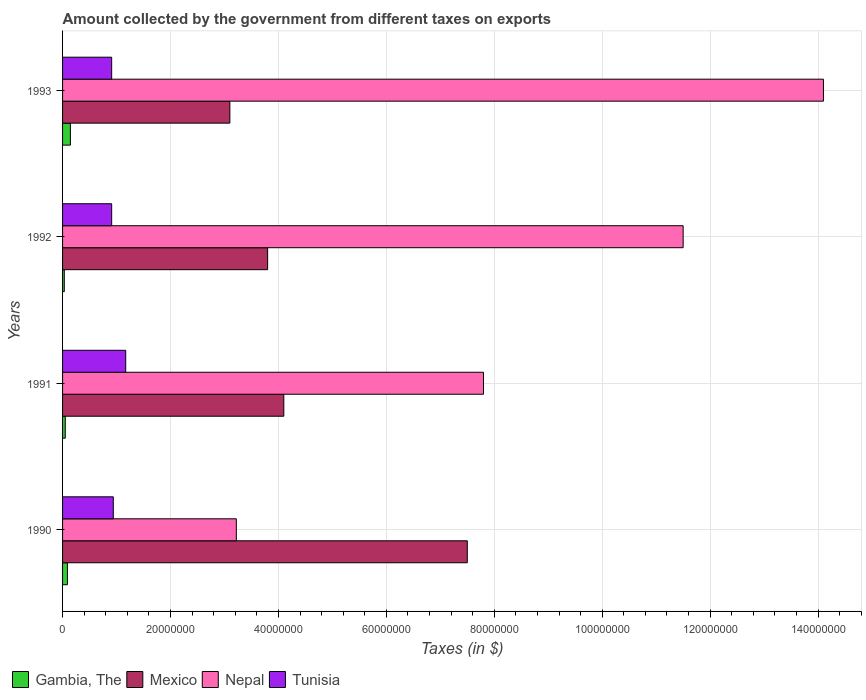How many groups of bars are there?
Your answer should be very brief. 4. Are the number of bars per tick equal to the number of legend labels?
Ensure brevity in your answer.  Yes. Are the number of bars on each tick of the Y-axis equal?
Provide a succinct answer. Yes. What is the amount collected by the government from taxes on exports in Gambia, The in 1990?
Your answer should be very brief. 9.00e+05. Across all years, what is the maximum amount collected by the government from taxes on exports in Gambia, The?
Offer a very short reply. 1.45e+06. Across all years, what is the minimum amount collected by the government from taxes on exports in Gambia, The?
Keep it short and to the point. 3.20e+05. In which year was the amount collected by the government from taxes on exports in Tunisia minimum?
Your answer should be compact. 1992. What is the total amount collected by the government from taxes on exports in Mexico in the graph?
Ensure brevity in your answer.  1.85e+08. What is the difference between the amount collected by the government from taxes on exports in Gambia, The in 1991 and that in 1993?
Give a very brief answer. -9.50e+05. What is the difference between the amount collected by the government from taxes on exports in Gambia, The in 1993 and the amount collected by the government from taxes on exports in Nepal in 1992?
Ensure brevity in your answer.  -1.14e+08. What is the average amount collected by the government from taxes on exports in Nepal per year?
Keep it short and to the point. 9.16e+07. In the year 1991, what is the difference between the amount collected by the government from taxes on exports in Nepal and amount collected by the government from taxes on exports in Mexico?
Your response must be concise. 3.70e+07. What is the ratio of the amount collected by the government from taxes on exports in Nepal in 1990 to that in 1992?
Your answer should be very brief. 0.28. Is the amount collected by the government from taxes on exports in Gambia, The in 1990 less than that in 1992?
Your response must be concise. No. What is the difference between the highest and the second highest amount collected by the government from taxes on exports in Mexico?
Your answer should be very brief. 3.40e+07. What is the difference between the highest and the lowest amount collected by the government from taxes on exports in Tunisia?
Make the answer very short. 2.60e+06. In how many years, is the amount collected by the government from taxes on exports in Nepal greater than the average amount collected by the government from taxes on exports in Nepal taken over all years?
Your response must be concise. 2. Is it the case that in every year, the sum of the amount collected by the government from taxes on exports in Gambia, The and amount collected by the government from taxes on exports in Tunisia is greater than the sum of amount collected by the government from taxes on exports in Nepal and amount collected by the government from taxes on exports in Mexico?
Keep it short and to the point. No. What does the 2nd bar from the top in 1992 represents?
Offer a very short reply. Nepal. What does the 4th bar from the bottom in 1991 represents?
Provide a short and direct response. Tunisia. Is it the case that in every year, the sum of the amount collected by the government from taxes on exports in Nepal and amount collected by the government from taxes on exports in Tunisia is greater than the amount collected by the government from taxes on exports in Gambia, The?
Ensure brevity in your answer.  Yes. How many bars are there?
Ensure brevity in your answer.  16. Are all the bars in the graph horizontal?
Provide a succinct answer. Yes. What is the difference between two consecutive major ticks on the X-axis?
Your answer should be compact. 2.00e+07. Are the values on the major ticks of X-axis written in scientific E-notation?
Provide a short and direct response. No. What is the title of the graph?
Provide a short and direct response. Amount collected by the government from different taxes on exports. What is the label or title of the X-axis?
Make the answer very short. Taxes (in $). What is the Taxes (in $) of Gambia, The in 1990?
Your answer should be compact. 9.00e+05. What is the Taxes (in $) of Mexico in 1990?
Your answer should be very brief. 7.50e+07. What is the Taxes (in $) in Nepal in 1990?
Provide a succinct answer. 3.22e+07. What is the Taxes (in $) of Tunisia in 1990?
Your response must be concise. 9.40e+06. What is the Taxes (in $) in Gambia, The in 1991?
Offer a very short reply. 5.00e+05. What is the Taxes (in $) of Mexico in 1991?
Ensure brevity in your answer.  4.10e+07. What is the Taxes (in $) in Nepal in 1991?
Keep it short and to the point. 7.80e+07. What is the Taxes (in $) of Tunisia in 1991?
Your answer should be compact. 1.17e+07. What is the Taxes (in $) of Gambia, The in 1992?
Make the answer very short. 3.20e+05. What is the Taxes (in $) in Mexico in 1992?
Make the answer very short. 3.80e+07. What is the Taxes (in $) in Nepal in 1992?
Offer a very short reply. 1.15e+08. What is the Taxes (in $) in Tunisia in 1992?
Ensure brevity in your answer.  9.10e+06. What is the Taxes (in $) in Gambia, The in 1993?
Make the answer very short. 1.45e+06. What is the Taxes (in $) of Mexico in 1993?
Give a very brief answer. 3.10e+07. What is the Taxes (in $) of Nepal in 1993?
Keep it short and to the point. 1.41e+08. What is the Taxes (in $) in Tunisia in 1993?
Ensure brevity in your answer.  9.10e+06. Across all years, what is the maximum Taxes (in $) of Gambia, The?
Your response must be concise. 1.45e+06. Across all years, what is the maximum Taxes (in $) in Mexico?
Ensure brevity in your answer.  7.50e+07. Across all years, what is the maximum Taxes (in $) in Nepal?
Provide a succinct answer. 1.41e+08. Across all years, what is the maximum Taxes (in $) of Tunisia?
Ensure brevity in your answer.  1.17e+07. Across all years, what is the minimum Taxes (in $) in Mexico?
Your answer should be compact. 3.10e+07. Across all years, what is the minimum Taxes (in $) in Nepal?
Provide a short and direct response. 3.22e+07. Across all years, what is the minimum Taxes (in $) in Tunisia?
Provide a succinct answer. 9.10e+06. What is the total Taxes (in $) of Gambia, The in the graph?
Keep it short and to the point. 3.17e+06. What is the total Taxes (in $) of Mexico in the graph?
Provide a succinct answer. 1.85e+08. What is the total Taxes (in $) of Nepal in the graph?
Your response must be concise. 3.66e+08. What is the total Taxes (in $) of Tunisia in the graph?
Your response must be concise. 3.93e+07. What is the difference between the Taxes (in $) of Mexico in 1990 and that in 1991?
Offer a terse response. 3.40e+07. What is the difference between the Taxes (in $) in Nepal in 1990 and that in 1991?
Ensure brevity in your answer.  -4.58e+07. What is the difference between the Taxes (in $) in Tunisia in 1990 and that in 1991?
Provide a succinct answer. -2.30e+06. What is the difference between the Taxes (in $) of Gambia, The in 1990 and that in 1992?
Your response must be concise. 5.80e+05. What is the difference between the Taxes (in $) of Mexico in 1990 and that in 1992?
Your response must be concise. 3.70e+07. What is the difference between the Taxes (in $) in Nepal in 1990 and that in 1992?
Make the answer very short. -8.28e+07. What is the difference between the Taxes (in $) in Tunisia in 1990 and that in 1992?
Your answer should be very brief. 3.00e+05. What is the difference between the Taxes (in $) of Gambia, The in 1990 and that in 1993?
Offer a terse response. -5.50e+05. What is the difference between the Taxes (in $) in Mexico in 1990 and that in 1993?
Offer a terse response. 4.40e+07. What is the difference between the Taxes (in $) of Nepal in 1990 and that in 1993?
Your response must be concise. -1.09e+08. What is the difference between the Taxes (in $) of Nepal in 1991 and that in 1992?
Your answer should be compact. -3.70e+07. What is the difference between the Taxes (in $) in Tunisia in 1991 and that in 1992?
Your answer should be compact. 2.60e+06. What is the difference between the Taxes (in $) of Gambia, The in 1991 and that in 1993?
Provide a succinct answer. -9.50e+05. What is the difference between the Taxes (in $) of Nepal in 1991 and that in 1993?
Your answer should be compact. -6.30e+07. What is the difference between the Taxes (in $) in Tunisia in 1991 and that in 1993?
Keep it short and to the point. 2.60e+06. What is the difference between the Taxes (in $) of Gambia, The in 1992 and that in 1993?
Offer a very short reply. -1.13e+06. What is the difference between the Taxes (in $) in Mexico in 1992 and that in 1993?
Your answer should be compact. 7.00e+06. What is the difference between the Taxes (in $) in Nepal in 1992 and that in 1993?
Provide a short and direct response. -2.60e+07. What is the difference between the Taxes (in $) of Gambia, The in 1990 and the Taxes (in $) of Mexico in 1991?
Offer a very short reply. -4.01e+07. What is the difference between the Taxes (in $) in Gambia, The in 1990 and the Taxes (in $) in Nepal in 1991?
Keep it short and to the point. -7.71e+07. What is the difference between the Taxes (in $) in Gambia, The in 1990 and the Taxes (in $) in Tunisia in 1991?
Your answer should be very brief. -1.08e+07. What is the difference between the Taxes (in $) in Mexico in 1990 and the Taxes (in $) in Tunisia in 1991?
Ensure brevity in your answer.  6.33e+07. What is the difference between the Taxes (in $) in Nepal in 1990 and the Taxes (in $) in Tunisia in 1991?
Offer a terse response. 2.05e+07. What is the difference between the Taxes (in $) in Gambia, The in 1990 and the Taxes (in $) in Mexico in 1992?
Provide a succinct answer. -3.71e+07. What is the difference between the Taxes (in $) of Gambia, The in 1990 and the Taxes (in $) of Nepal in 1992?
Offer a very short reply. -1.14e+08. What is the difference between the Taxes (in $) of Gambia, The in 1990 and the Taxes (in $) of Tunisia in 1992?
Keep it short and to the point. -8.20e+06. What is the difference between the Taxes (in $) in Mexico in 1990 and the Taxes (in $) in Nepal in 1992?
Your answer should be very brief. -4.00e+07. What is the difference between the Taxes (in $) of Mexico in 1990 and the Taxes (in $) of Tunisia in 1992?
Offer a very short reply. 6.59e+07. What is the difference between the Taxes (in $) of Nepal in 1990 and the Taxes (in $) of Tunisia in 1992?
Offer a very short reply. 2.31e+07. What is the difference between the Taxes (in $) of Gambia, The in 1990 and the Taxes (in $) of Mexico in 1993?
Offer a terse response. -3.01e+07. What is the difference between the Taxes (in $) in Gambia, The in 1990 and the Taxes (in $) in Nepal in 1993?
Your answer should be compact. -1.40e+08. What is the difference between the Taxes (in $) of Gambia, The in 1990 and the Taxes (in $) of Tunisia in 1993?
Your answer should be compact. -8.20e+06. What is the difference between the Taxes (in $) in Mexico in 1990 and the Taxes (in $) in Nepal in 1993?
Offer a terse response. -6.60e+07. What is the difference between the Taxes (in $) in Mexico in 1990 and the Taxes (in $) in Tunisia in 1993?
Provide a succinct answer. 6.59e+07. What is the difference between the Taxes (in $) of Nepal in 1990 and the Taxes (in $) of Tunisia in 1993?
Your response must be concise. 2.31e+07. What is the difference between the Taxes (in $) of Gambia, The in 1991 and the Taxes (in $) of Mexico in 1992?
Ensure brevity in your answer.  -3.75e+07. What is the difference between the Taxes (in $) in Gambia, The in 1991 and the Taxes (in $) in Nepal in 1992?
Provide a short and direct response. -1.14e+08. What is the difference between the Taxes (in $) in Gambia, The in 1991 and the Taxes (in $) in Tunisia in 1992?
Your answer should be very brief. -8.60e+06. What is the difference between the Taxes (in $) of Mexico in 1991 and the Taxes (in $) of Nepal in 1992?
Provide a succinct answer. -7.40e+07. What is the difference between the Taxes (in $) in Mexico in 1991 and the Taxes (in $) in Tunisia in 1992?
Your response must be concise. 3.19e+07. What is the difference between the Taxes (in $) of Nepal in 1991 and the Taxes (in $) of Tunisia in 1992?
Your answer should be compact. 6.89e+07. What is the difference between the Taxes (in $) of Gambia, The in 1991 and the Taxes (in $) of Mexico in 1993?
Provide a succinct answer. -3.05e+07. What is the difference between the Taxes (in $) of Gambia, The in 1991 and the Taxes (in $) of Nepal in 1993?
Make the answer very short. -1.40e+08. What is the difference between the Taxes (in $) of Gambia, The in 1991 and the Taxes (in $) of Tunisia in 1993?
Ensure brevity in your answer.  -8.60e+06. What is the difference between the Taxes (in $) in Mexico in 1991 and the Taxes (in $) in Nepal in 1993?
Give a very brief answer. -1.00e+08. What is the difference between the Taxes (in $) in Mexico in 1991 and the Taxes (in $) in Tunisia in 1993?
Give a very brief answer. 3.19e+07. What is the difference between the Taxes (in $) in Nepal in 1991 and the Taxes (in $) in Tunisia in 1993?
Your answer should be compact. 6.89e+07. What is the difference between the Taxes (in $) of Gambia, The in 1992 and the Taxes (in $) of Mexico in 1993?
Your answer should be compact. -3.07e+07. What is the difference between the Taxes (in $) in Gambia, The in 1992 and the Taxes (in $) in Nepal in 1993?
Your answer should be very brief. -1.41e+08. What is the difference between the Taxes (in $) in Gambia, The in 1992 and the Taxes (in $) in Tunisia in 1993?
Your answer should be compact. -8.78e+06. What is the difference between the Taxes (in $) of Mexico in 1992 and the Taxes (in $) of Nepal in 1993?
Your answer should be very brief. -1.03e+08. What is the difference between the Taxes (in $) in Mexico in 1992 and the Taxes (in $) in Tunisia in 1993?
Your answer should be compact. 2.89e+07. What is the difference between the Taxes (in $) of Nepal in 1992 and the Taxes (in $) of Tunisia in 1993?
Your response must be concise. 1.06e+08. What is the average Taxes (in $) of Gambia, The per year?
Your response must be concise. 7.92e+05. What is the average Taxes (in $) of Mexico per year?
Make the answer very short. 4.62e+07. What is the average Taxes (in $) of Nepal per year?
Ensure brevity in your answer.  9.16e+07. What is the average Taxes (in $) in Tunisia per year?
Ensure brevity in your answer.  9.82e+06. In the year 1990, what is the difference between the Taxes (in $) in Gambia, The and Taxes (in $) in Mexico?
Provide a succinct answer. -7.41e+07. In the year 1990, what is the difference between the Taxes (in $) in Gambia, The and Taxes (in $) in Nepal?
Make the answer very short. -3.13e+07. In the year 1990, what is the difference between the Taxes (in $) of Gambia, The and Taxes (in $) of Tunisia?
Offer a terse response. -8.50e+06. In the year 1990, what is the difference between the Taxes (in $) in Mexico and Taxes (in $) in Nepal?
Ensure brevity in your answer.  4.28e+07. In the year 1990, what is the difference between the Taxes (in $) in Mexico and Taxes (in $) in Tunisia?
Your response must be concise. 6.56e+07. In the year 1990, what is the difference between the Taxes (in $) in Nepal and Taxes (in $) in Tunisia?
Keep it short and to the point. 2.28e+07. In the year 1991, what is the difference between the Taxes (in $) of Gambia, The and Taxes (in $) of Mexico?
Your answer should be compact. -4.05e+07. In the year 1991, what is the difference between the Taxes (in $) in Gambia, The and Taxes (in $) in Nepal?
Provide a succinct answer. -7.75e+07. In the year 1991, what is the difference between the Taxes (in $) in Gambia, The and Taxes (in $) in Tunisia?
Give a very brief answer. -1.12e+07. In the year 1991, what is the difference between the Taxes (in $) of Mexico and Taxes (in $) of Nepal?
Ensure brevity in your answer.  -3.70e+07. In the year 1991, what is the difference between the Taxes (in $) in Mexico and Taxes (in $) in Tunisia?
Your answer should be very brief. 2.93e+07. In the year 1991, what is the difference between the Taxes (in $) of Nepal and Taxes (in $) of Tunisia?
Provide a short and direct response. 6.63e+07. In the year 1992, what is the difference between the Taxes (in $) in Gambia, The and Taxes (in $) in Mexico?
Your answer should be very brief. -3.77e+07. In the year 1992, what is the difference between the Taxes (in $) in Gambia, The and Taxes (in $) in Nepal?
Give a very brief answer. -1.15e+08. In the year 1992, what is the difference between the Taxes (in $) in Gambia, The and Taxes (in $) in Tunisia?
Your answer should be compact. -8.78e+06. In the year 1992, what is the difference between the Taxes (in $) in Mexico and Taxes (in $) in Nepal?
Provide a short and direct response. -7.70e+07. In the year 1992, what is the difference between the Taxes (in $) in Mexico and Taxes (in $) in Tunisia?
Ensure brevity in your answer.  2.89e+07. In the year 1992, what is the difference between the Taxes (in $) of Nepal and Taxes (in $) of Tunisia?
Provide a short and direct response. 1.06e+08. In the year 1993, what is the difference between the Taxes (in $) in Gambia, The and Taxes (in $) in Mexico?
Give a very brief answer. -2.96e+07. In the year 1993, what is the difference between the Taxes (in $) of Gambia, The and Taxes (in $) of Nepal?
Your answer should be compact. -1.40e+08. In the year 1993, what is the difference between the Taxes (in $) of Gambia, The and Taxes (in $) of Tunisia?
Make the answer very short. -7.65e+06. In the year 1993, what is the difference between the Taxes (in $) of Mexico and Taxes (in $) of Nepal?
Ensure brevity in your answer.  -1.10e+08. In the year 1993, what is the difference between the Taxes (in $) in Mexico and Taxes (in $) in Tunisia?
Provide a short and direct response. 2.19e+07. In the year 1993, what is the difference between the Taxes (in $) in Nepal and Taxes (in $) in Tunisia?
Your response must be concise. 1.32e+08. What is the ratio of the Taxes (in $) of Gambia, The in 1990 to that in 1991?
Your answer should be very brief. 1.8. What is the ratio of the Taxes (in $) in Mexico in 1990 to that in 1991?
Provide a short and direct response. 1.83. What is the ratio of the Taxes (in $) in Nepal in 1990 to that in 1991?
Provide a succinct answer. 0.41. What is the ratio of the Taxes (in $) in Tunisia in 1990 to that in 1991?
Make the answer very short. 0.8. What is the ratio of the Taxes (in $) of Gambia, The in 1990 to that in 1992?
Provide a short and direct response. 2.81. What is the ratio of the Taxes (in $) of Mexico in 1990 to that in 1992?
Make the answer very short. 1.97. What is the ratio of the Taxes (in $) in Nepal in 1990 to that in 1992?
Make the answer very short. 0.28. What is the ratio of the Taxes (in $) in Tunisia in 1990 to that in 1992?
Your answer should be very brief. 1.03. What is the ratio of the Taxes (in $) in Gambia, The in 1990 to that in 1993?
Your answer should be very brief. 0.62. What is the ratio of the Taxes (in $) in Mexico in 1990 to that in 1993?
Offer a very short reply. 2.42. What is the ratio of the Taxes (in $) of Nepal in 1990 to that in 1993?
Ensure brevity in your answer.  0.23. What is the ratio of the Taxes (in $) of Tunisia in 1990 to that in 1993?
Provide a succinct answer. 1.03. What is the ratio of the Taxes (in $) of Gambia, The in 1991 to that in 1992?
Provide a succinct answer. 1.56. What is the ratio of the Taxes (in $) in Mexico in 1991 to that in 1992?
Provide a succinct answer. 1.08. What is the ratio of the Taxes (in $) in Nepal in 1991 to that in 1992?
Your answer should be compact. 0.68. What is the ratio of the Taxes (in $) in Tunisia in 1991 to that in 1992?
Provide a short and direct response. 1.29. What is the ratio of the Taxes (in $) of Gambia, The in 1991 to that in 1993?
Offer a terse response. 0.34. What is the ratio of the Taxes (in $) of Mexico in 1991 to that in 1993?
Offer a very short reply. 1.32. What is the ratio of the Taxes (in $) of Nepal in 1991 to that in 1993?
Your answer should be very brief. 0.55. What is the ratio of the Taxes (in $) in Gambia, The in 1992 to that in 1993?
Provide a succinct answer. 0.22. What is the ratio of the Taxes (in $) of Mexico in 1992 to that in 1993?
Your answer should be compact. 1.23. What is the ratio of the Taxes (in $) of Nepal in 1992 to that in 1993?
Your answer should be compact. 0.82. What is the difference between the highest and the second highest Taxes (in $) of Mexico?
Keep it short and to the point. 3.40e+07. What is the difference between the highest and the second highest Taxes (in $) in Nepal?
Offer a very short reply. 2.60e+07. What is the difference between the highest and the second highest Taxes (in $) in Tunisia?
Make the answer very short. 2.30e+06. What is the difference between the highest and the lowest Taxes (in $) of Gambia, The?
Provide a short and direct response. 1.13e+06. What is the difference between the highest and the lowest Taxes (in $) in Mexico?
Offer a very short reply. 4.40e+07. What is the difference between the highest and the lowest Taxes (in $) in Nepal?
Your response must be concise. 1.09e+08. What is the difference between the highest and the lowest Taxes (in $) of Tunisia?
Keep it short and to the point. 2.60e+06. 